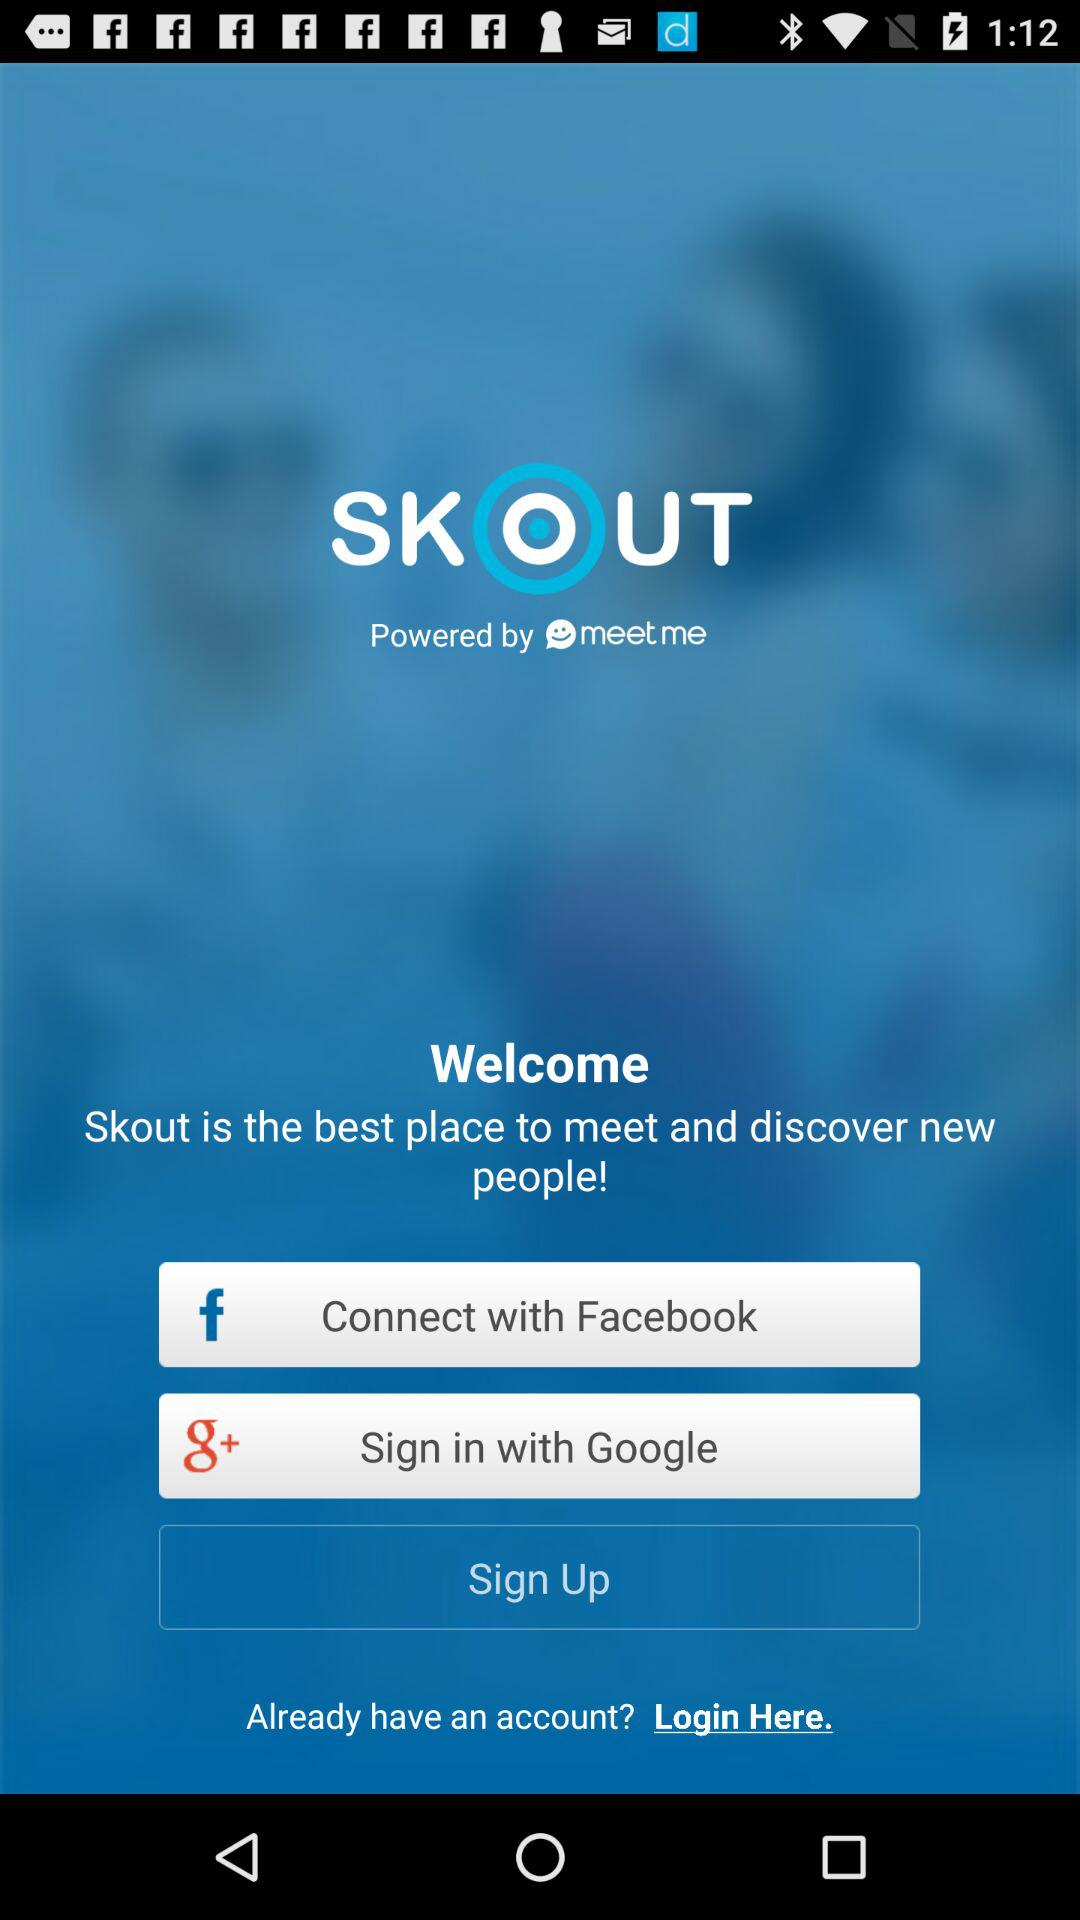What is the name of the application? The name of the application is "SKOUT". 